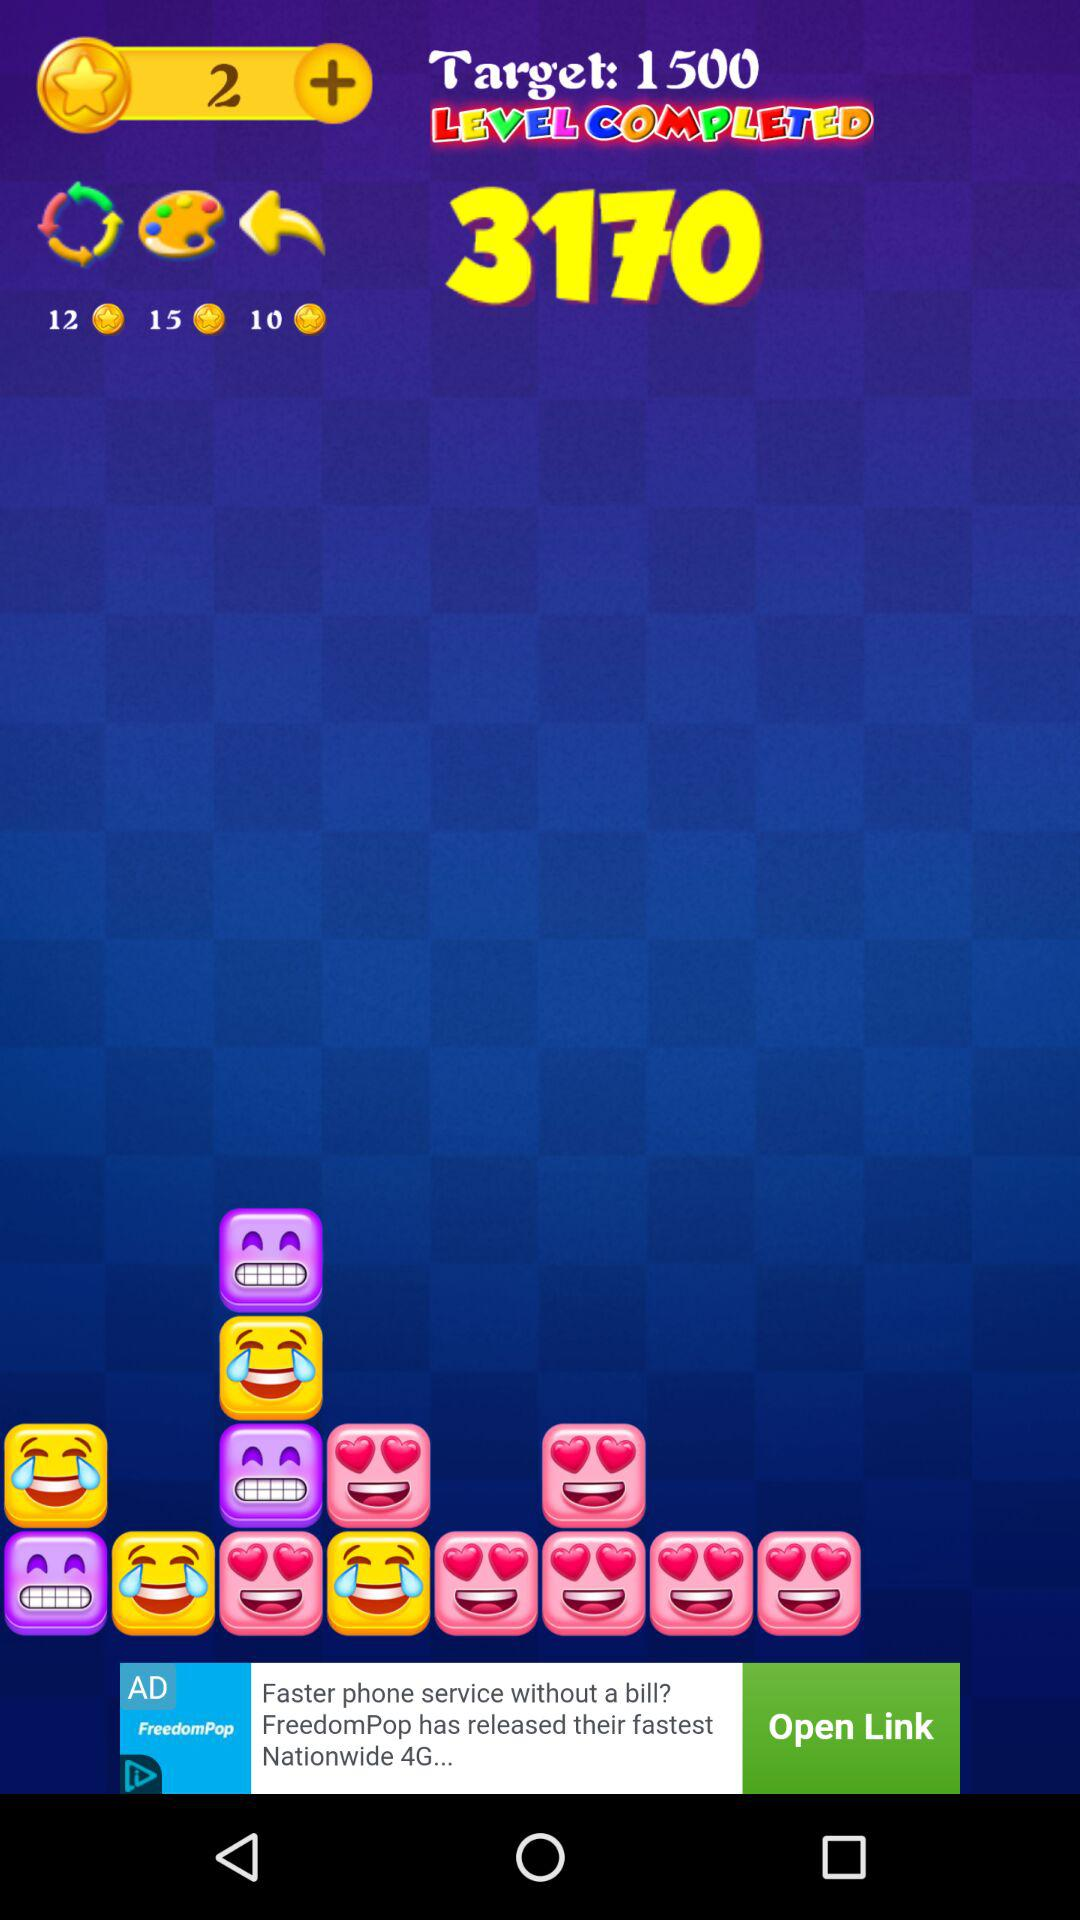On which level is the person?
When the provided information is insufficient, respond with <no answer>. <no answer> 